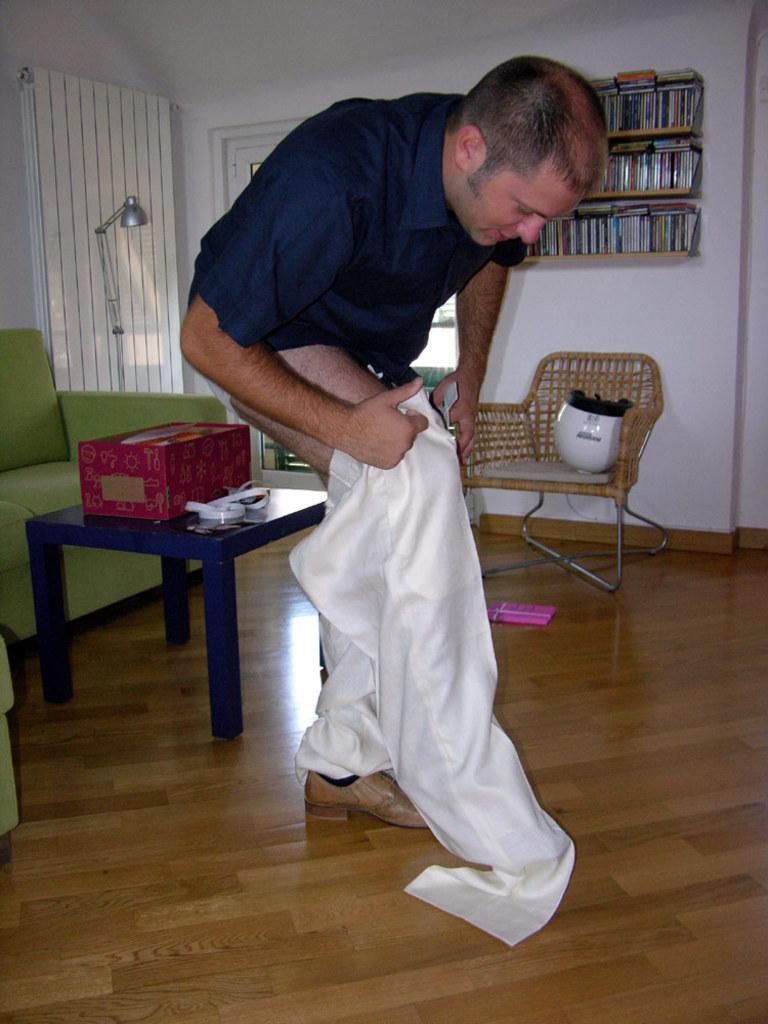Describe this image in one or two sentences. In the center of the picture we can see a person wearing pant. On the left there are couch, table, box and other objects. At the bottom it is floor. In the background there are books, bookshelves, door, window blind, lamp, chair, helmet and other objects. 